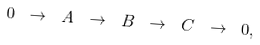<formula> <loc_0><loc_0><loc_500><loc_500>0 \ \rightarrow \ A \ \rightarrow \ B \ \rightarrow \ C \ \rightarrow \ 0 ,</formula> 